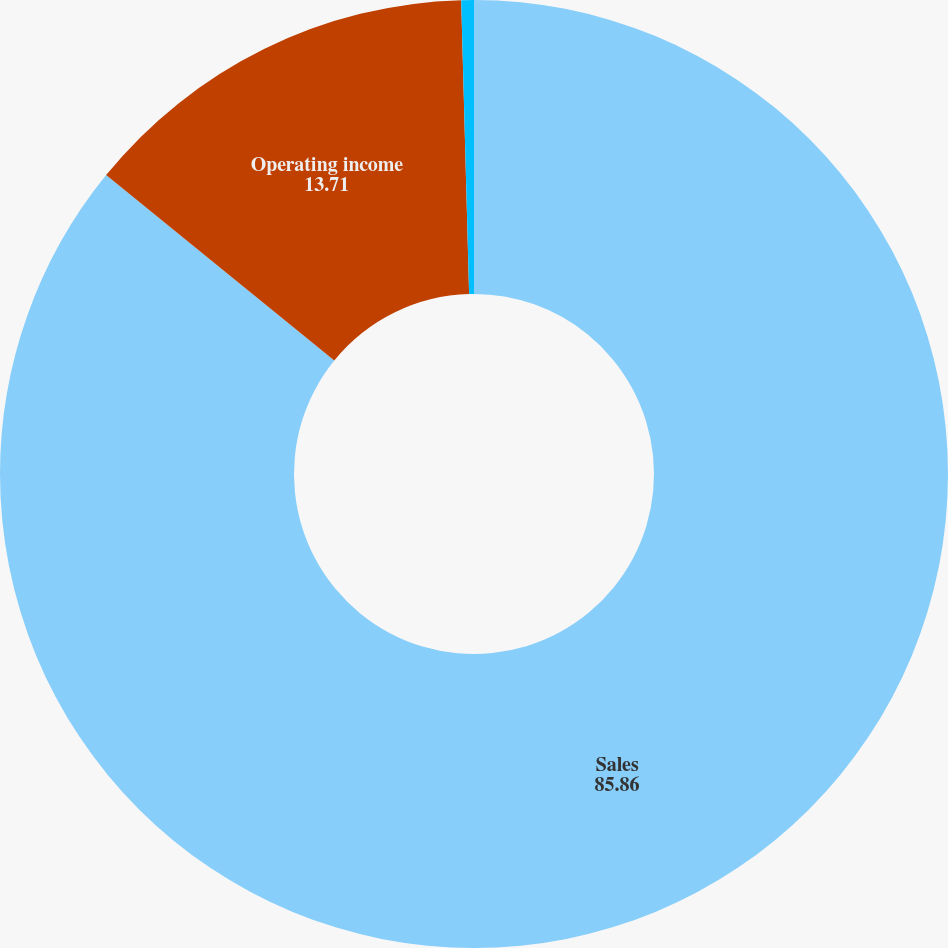<chart> <loc_0><loc_0><loc_500><loc_500><pie_chart><fcel>Sales<fcel>Operating income<fcel>Operating margin<nl><fcel>85.86%<fcel>13.71%<fcel>0.43%<nl></chart> 